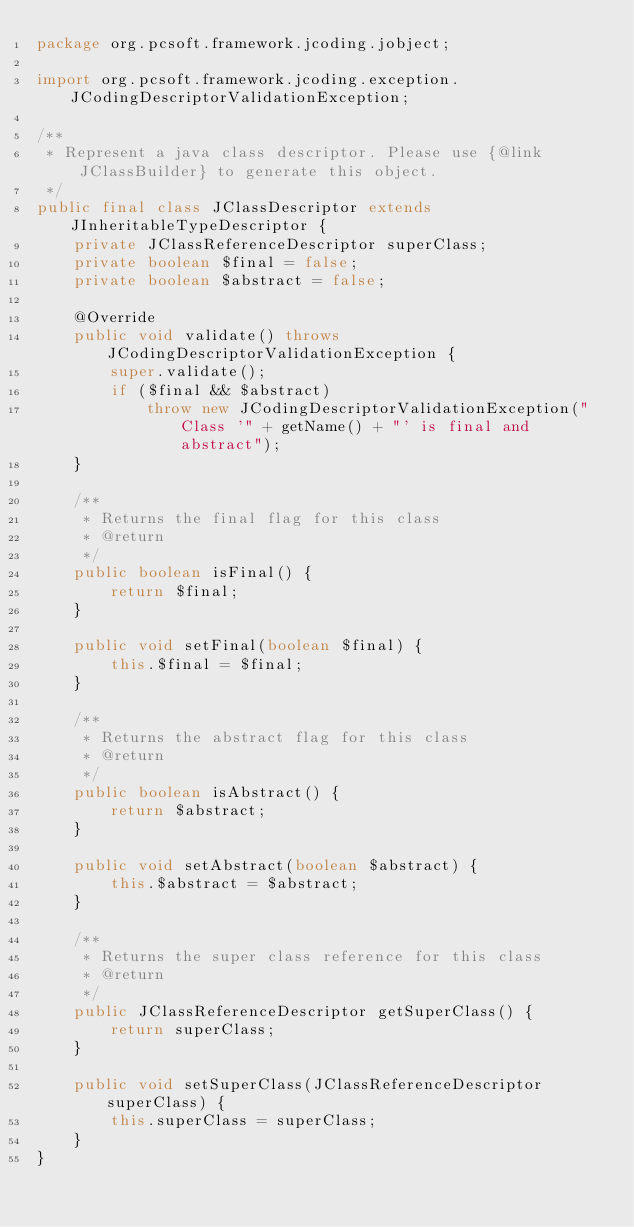Convert code to text. <code><loc_0><loc_0><loc_500><loc_500><_Java_>package org.pcsoft.framework.jcoding.jobject;

import org.pcsoft.framework.jcoding.exception.JCodingDescriptorValidationException;

/**
 * Represent a java class descriptor. Please use {@link JClassBuilder} to generate this object.
 */
public final class JClassDescriptor extends JInheritableTypeDescriptor {
    private JClassReferenceDescriptor superClass;
    private boolean $final = false;
    private boolean $abstract = false;

    @Override
    public void validate() throws JCodingDescriptorValidationException {
        super.validate();
        if ($final && $abstract)
            throw new JCodingDescriptorValidationException("Class '" + getName() + "' is final and abstract");
    }

    /**
     * Returns the final flag for this class
     * @return
     */
    public boolean isFinal() {
        return $final;
    }

    public void setFinal(boolean $final) {
        this.$final = $final;
    }

    /**
     * Returns the abstract flag for this class
     * @return
     */
    public boolean isAbstract() {
        return $abstract;
    }

    public void setAbstract(boolean $abstract) {
        this.$abstract = $abstract;
    }

    /**
     * Returns the super class reference for this class
     * @return
     */
    public JClassReferenceDescriptor getSuperClass() {
        return superClass;
    }

    public void setSuperClass(JClassReferenceDescriptor superClass) {
        this.superClass = superClass;
    }
}
</code> 